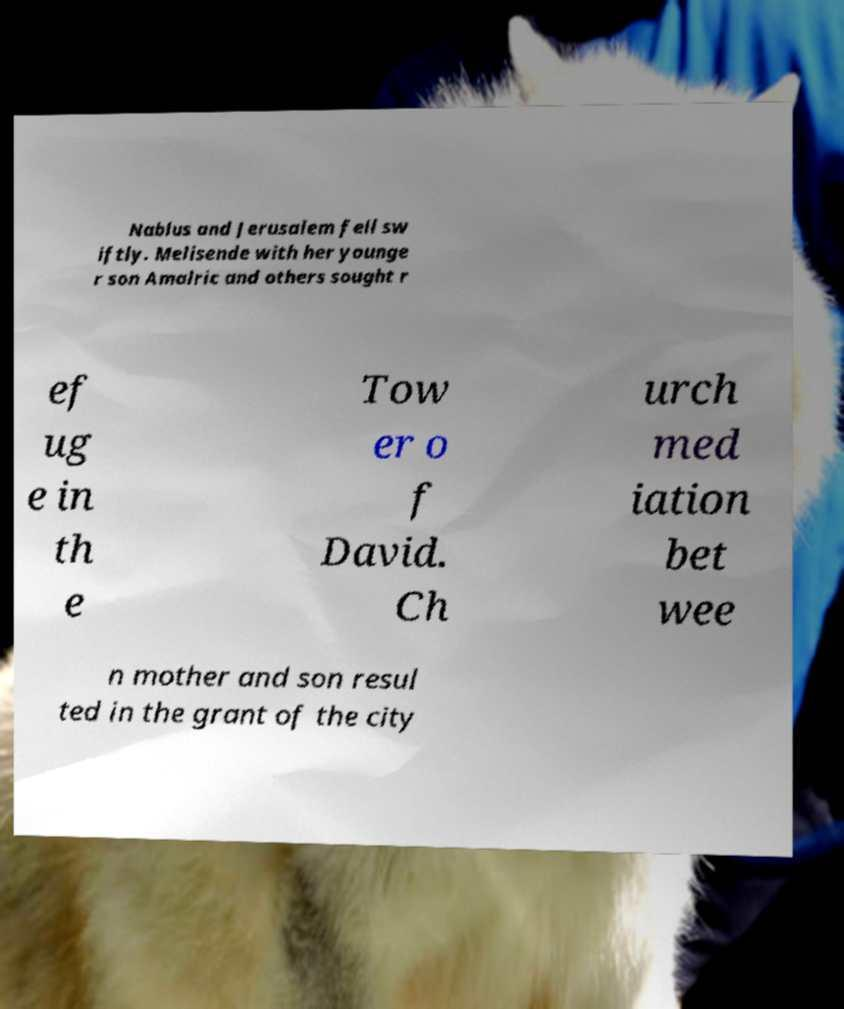For documentation purposes, I need the text within this image transcribed. Could you provide that? Nablus and Jerusalem fell sw iftly. Melisende with her younge r son Amalric and others sought r ef ug e in th e Tow er o f David. Ch urch med iation bet wee n mother and son resul ted in the grant of the city 